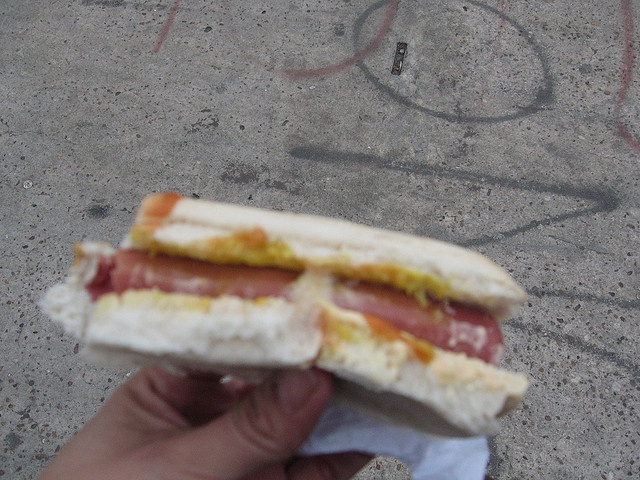Describe the objects in this image and their specific colors. I can see sandwich in gray, darkgray, brown, and lightgray tones, hot dog in gray, darkgray, brown, and lightgray tones, and people in gray, brown, maroon, and black tones in this image. 